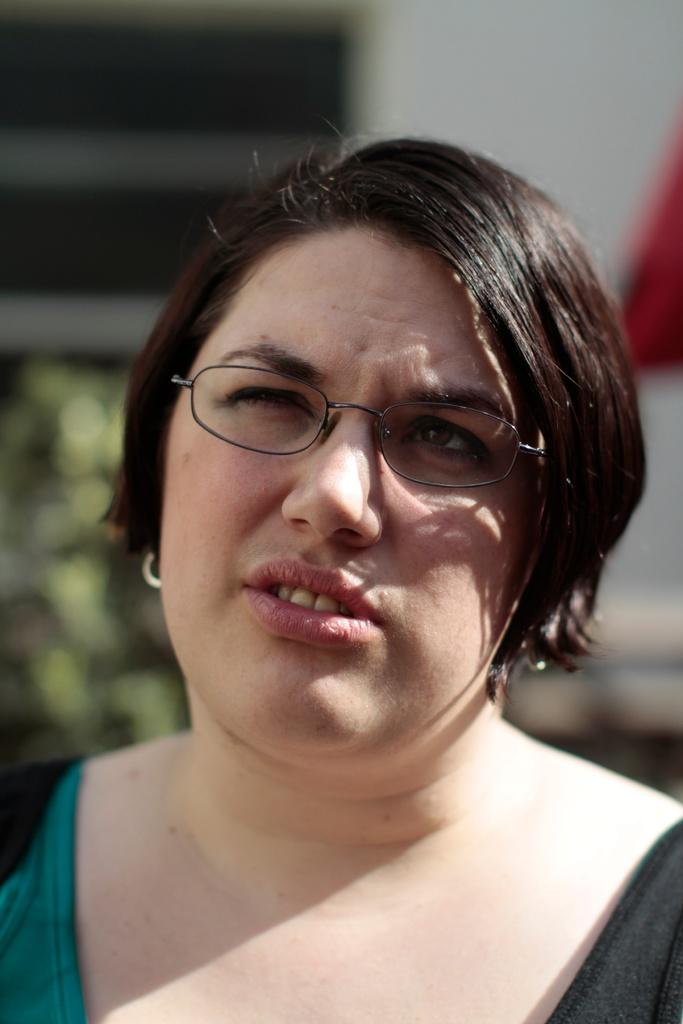What is the main subject of the image? There is a lady person in the image. What is the lady person wearing? The lady person is wearing a black and green color dress. Are there any accessories visible on the lady person? Yes, the lady person is wearing spectacles. Can you describe the background of the image? The background of the image is blurry. What type of yoke is being used by the lady person in the image? There is no yoke present in the image. How does the lady person show care for the environment in the image? The image does not provide any information about the lady person's actions or intentions regarding the environment. 